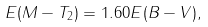Convert formula to latex. <formula><loc_0><loc_0><loc_500><loc_500>E ( M - T _ { 2 } ) = 1 . 6 0 E ( B - V ) ,</formula> 